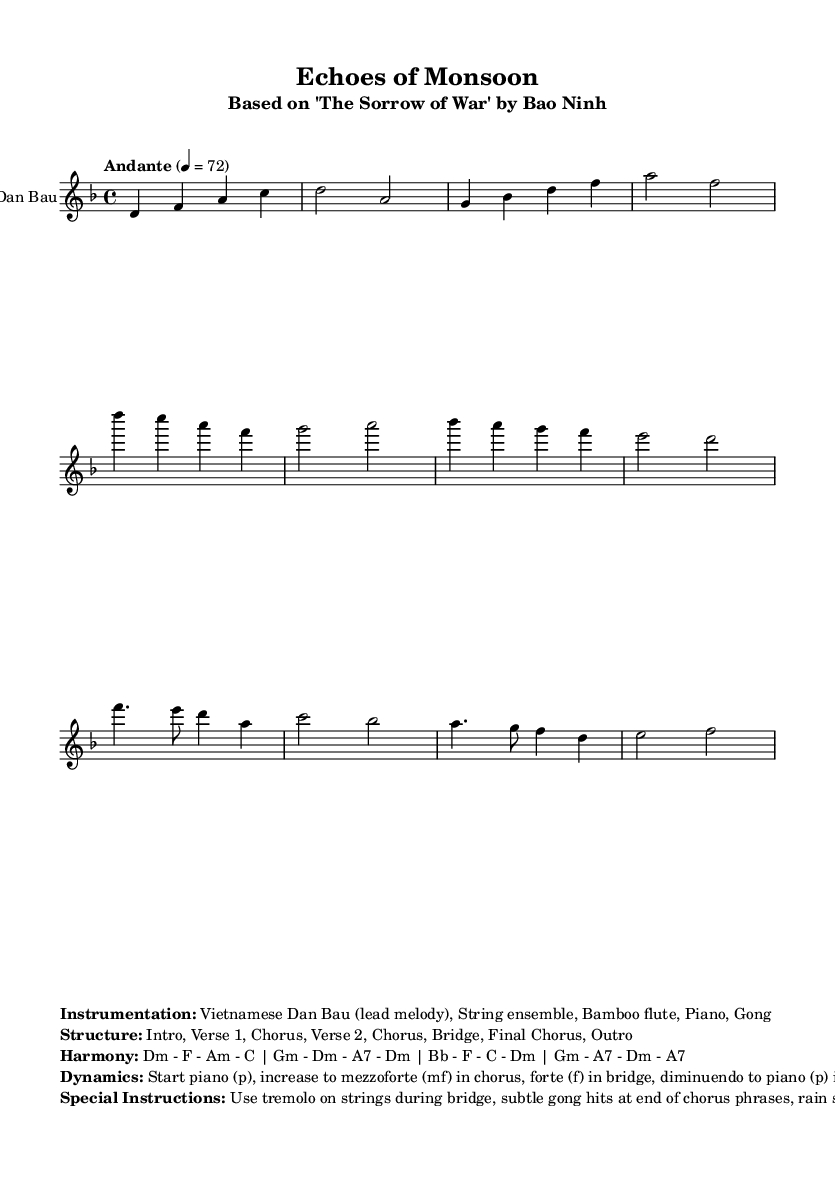What is the key signature of this music? The key signature is D minor, indicated by one flat (B flat). It is a minor scale centered around the note D.
Answer: D minor What is the time signature of this music? The time signature is 4/4, which means there are four beats in each measure and a quarter note gets one beat.
Answer: 4/4 What is the tempo marking of this piece? The tempo marking is "Andante," which indicates a moderate walking pace, typically around 76 to 108 beats per minute. The sheet specifies 4 beats per minute equating to 72 BPM.
Answer: Andante What is the instrumentation used in this score? The instrumentation is listed as "Vietnamese Dan Bau (lead melody), String ensemble, Bamboo flute, Piano, Gong." This gives clarity on the types of instruments involved in the performance of the music.
Answer: Vietnamese Dan Bau, String ensemble, Bamboo flute, Piano, Gong How many sections are in the structure of this music? The structure of the music consists of eight labeled sections: Intro, Verse 1, Chorus, Verse 2, Chorus, Bridge, Final Chorus, and Outro, totaling eight distinct parts.
Answer: Eight What are the dynamics indicated in the sheet music? The dynamics indicated include starting piano, increasing to mezzoforte in the chorus, going to forte in the bridge, and then diminuendo to piano in the outro. This reflects the intended variations in volume throughout the piece.
Answer: Piano, mezzoforte, forte, diminuendo What is the special instruction regarding string instruments during the bridge? The special instruction for the string instruments during the bridge is to use tremolo. This technique adds a shimmering, trembling effect, enhancing the emotional impact of that section.
Answer: Use tremolo 